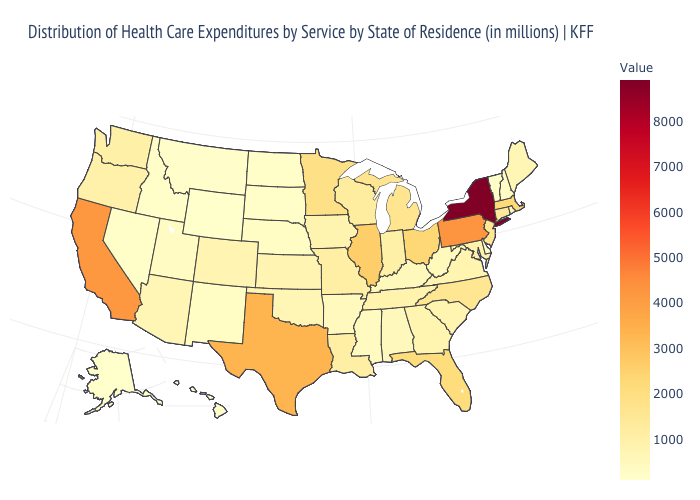Among the states that border Montana , does Wyoming have the lowest value?
Be succinct. Yes. Is the legend a continuous bar?
Be succinct. Yes. Does the map have missing data?
Keep it brief. No. Among the states that border Idaho , does Utah have the lowest value?
Short answer required. No. Among the states that border Kentucky , does Tennessee have the highest value?
Keep it brief. No. 